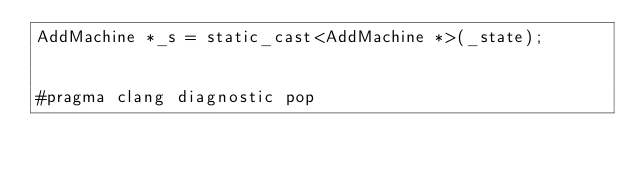Convert code to text. <code><loc_0><loc_0><loc_500><loc_500><_ObjectiveC_>AddMachine *_s = static_cast<AddMachine *>(_state);


#pragma clang diagnostic pop
</code> 